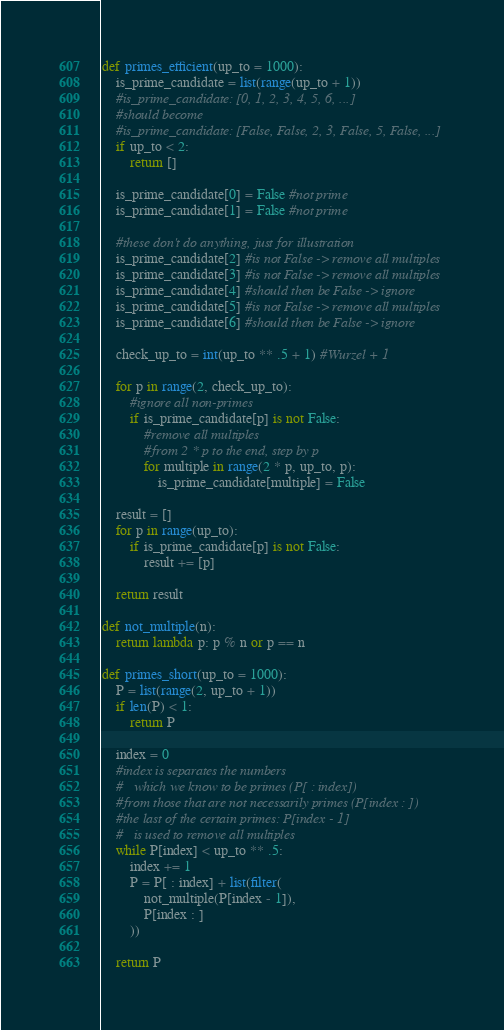Convert code to text. <code><loc_0><loc_0><loc_500><loc_500><_Python_>def primes_efficient(up_to = 1000):
    is_prime_candidate = list(range(up_to + 1))
    #is_prime_candidate: [0, 1, 2, 3, 4, 5, 6, ...]
    #should become
    #is_prime_candidate: [False, False, 2, 3, False, 5, False, ...]
    if up_to < 2:
        return []

    is_prime_candidate[0] = False #not prime
    is_prime_candidate[1] = False #not prime

    #these don't do anything, just for illustration
    is_prime_candidate[2] #is not False -> remove all multiples
    is_prime_candidate[3] #is not False -> remove all multiples
    is_prime_candidate[4] #should then be False -> ignore
    is_prime_candidate[5] #is not False -> remove all multiples
    is_prime_candidate[6] #should then be False -> ignore

    check_up_to = int(up_to ** .5 + 1) #Wurzel + 1

    for p in range(2, check_up_to):
        #ignore all non-primes
        if is_prime_candidate[p] is not False:
            #remove all multiples
            #from 2 * p to the end, step by p
            for multiple in range(2 * p, up_to, p):
                is_prime_candidate[multiple] = False

    result = []
    for p in range(up_to):
        if is_prime_candidate[p] is not False:
            result += [p]

    return result

def not_multiple(n):
    return lambda p: p % n or p == n

def primes_short(up_to = 1000):
    P = list(range(2, up_to + 1))
    if len(P) < 1:
        return P

    index = 0
    #index is separates the numbers
    #   which we know to be primes (P[ : index])
    #from those that are not necessarily primes (P[index : ])
    #the last of the certain primes: P[index - 1]
    #   is used to remove all multiples
    while P[index] < up_to ** .5:
        index += 1
        P = P[ : index] + list(filter(
            not_multiple(P[index - 1]),
            P[index : ]
        ))

    return P
</code> 